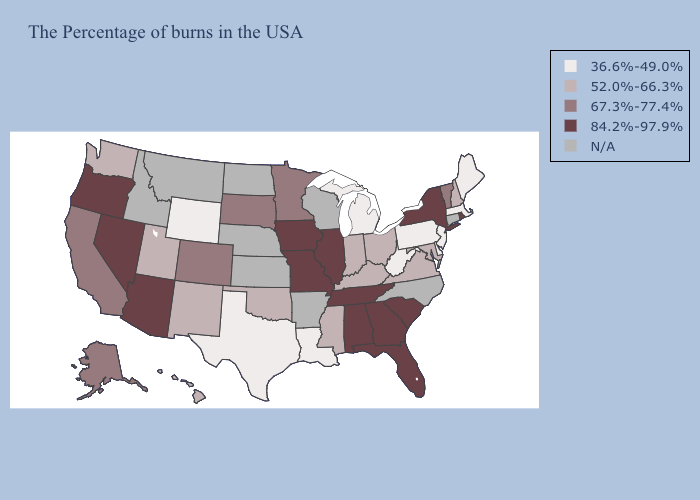Among the states that border Connecticut , does New York have the highest value?
Give a very brief answer. Yes. Does Utah have the lowest value in the USA?
Give a very brief answer. No. What is the lowest value in the MidWest?
Give a very brief answer. 36.6%-49.0%. Does Alaska have the highest value in the West?
Be succinct. No. Name the states that have a value in the range 52.0%-66.3%?
Answer briefly. New Hampshire, Maryland, Virginia, Ohio, Kentucky, Indiana, Mississippi, Oklahoma, New Mexico, Utah, Washington, Hawaii. Which states have the lowest value in the West?
Keep it brief. Wyoming. Name the states that have a value in the range 84.2%-97.9%?
Answer briefly. Rhode Island, New York, South Carolina, Florida, Georgia, Alabama, Tennessee, Illinois, Missouri, Iowa, Arizona, Nevada, Oregon. Does the map have missing data?
Be succinct. Yes. Does Wyoming have the lowest value in the West?
Give a very brief answer. Yes. Which states have the lowest value in the USA?
Give a very brief answer. Maine, Massachusetts, New Jersey, Delaware, Pennsylvania, West Virginia, Michigan, Louisiana, Texas, Wyoming. Among the states that border Rhode Island , which have the lowest value?
Quick response, please. Massachusetts. What is the lowest value in the MidWest?
Give a very brief answer. 36.6%-49.0%. Among the states that border Minnesota , does South Dakota have the highest value?
Answer briefly. No. What is the value of North Carolina?
Quick response, please. N/A. 